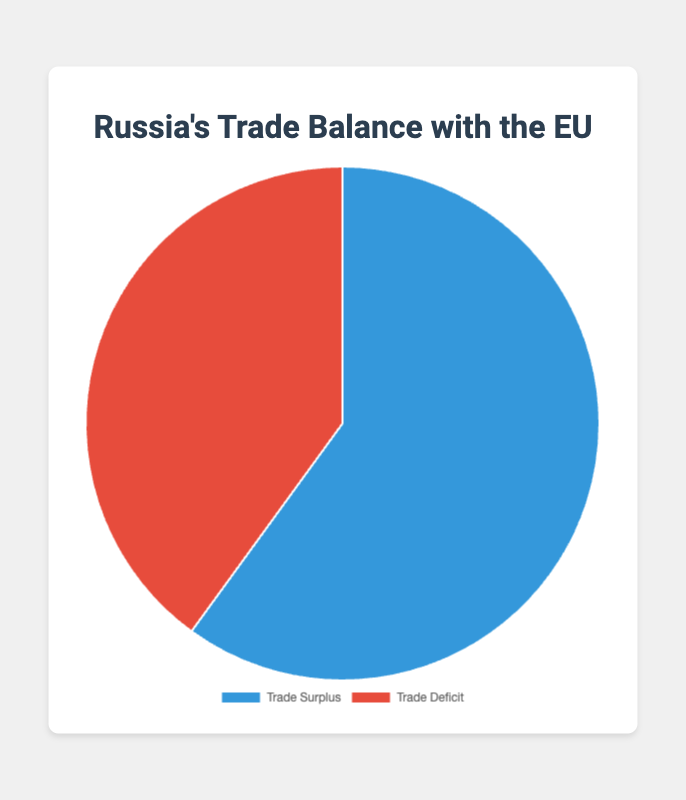What is the total trade value for both Trade Surplus and Trade Deficit combined? Add the Trade Surplus (120,000,000) and the Trade Deficit (80,000,000) to find the total. 120,000,000 + 80,000,000 = 200,000,000
Answer: 200,000,000 Which has a higher value, Trade Surplus or Trade Deficit? Compare the values of Trade Surplus (120,000,000) and Trade Deficit (80,000,000). Trade Surplus is greater.
Answer: Trade Surplus What percentage of the total trade value is the Trade Surplus? Calculate the percentage by dividing the Trade Surplus (120,000,000) by the total trade value (200,000,000) and multiply by 100. (120,000,000 / 200,000,000) * 100 = 60%
Answer: 60% What is the color representing Trade Surplus in the pie chart? The pie chart uses two distinct colors for each segment. Trade Surplus is represented by the blue color.
Answer: Blue By how much does the Trade Surplus exceed the Trade Deficit? Subtract the Trade Deficit (80,000,000) from the Trade Surplus (120,000,000). 120,000,000 - 80,000,000 = 40,000,000
Answer: 40,000,000 If the Trade Deficit increased by 50%, what would the new value be? Calculate 50% of the Trade Deficit (80,000,000). 0.5 * 80,000,000 = 40,000,000. Add this to the original Trade Deficit. 80,000,000 + 40,000,000 = 120,000,000
Answer: 120,000,000 What is the ratio of Trade Surplus to Trade Deficit? Divide the value of the Trade Surplus (120,000,000) by the Trade Deficit (80,000,000). 120,000,000 / 80,000,000 = 1.5
Answer: 1.5 What would be the new total trade value if the Trade Surplus decreased by 20%? Calculate 20% of the Trade Surplus (120,000,000). 0.2 * 120,000,000 = 24,000,000. Subtract this from the original Trade Surplus value. 120,000,000 - 24,000,000 = 96,000,000. Add the Trade Deficit to this new value. 96,000,000 + 80,000,000 = 176,000,000
Answer: 176,000,000 